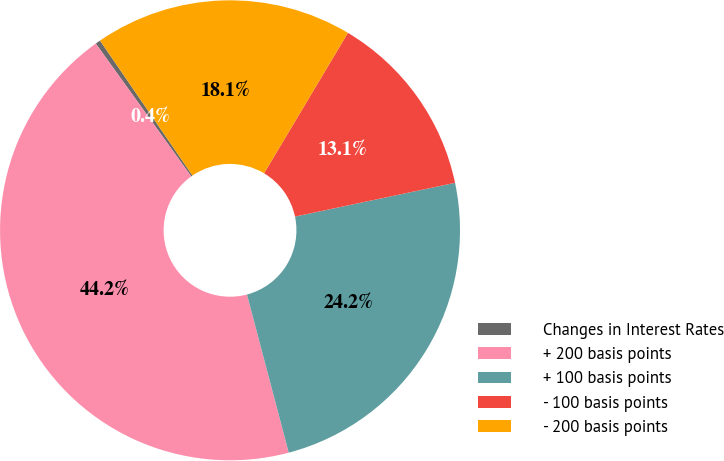Convert chart. <chart><loc_0><loc_0><loc_500><loc_500><pie_chart><fcel>Changes in Interest Rates<fcel>+ 200 basis points<fcel>+ 100 basis points<fcel>- 100 basis points<fcel>- 200 basis points<nl><fcel>0.36%<fcel>44.19%<fcel>24.2%<fcel>13.12%<fcel>18.13%<nl></chart> 